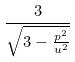Convert formula to latex. <formula><loc_0><loc_0><loc_500><loc_500>\frac { 3 } { \sqrt { 3 - \frac { p ^ { 2 } } { u ^ { 2 } } } }</formula> 